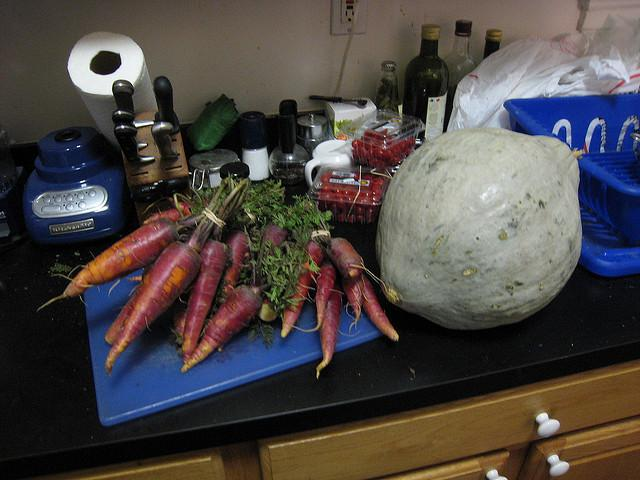Which food is rich in vitamin A?

Choices:
A) cilantro
B) melon
C) carrot
D) tomato carrot 